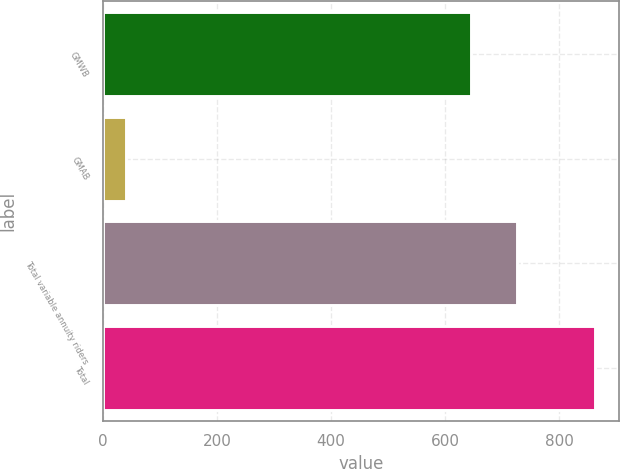Convert chart. <chart><loc_0><loc_0><loc_500><loc_500><bar_chart><fcel>GMWB<fcel>GMAB<fcel>Total variable annuity riders<fcel>Total<nl><fcel>645<fcel>41<fcel>727.2<fcel>863<nl></chart> 